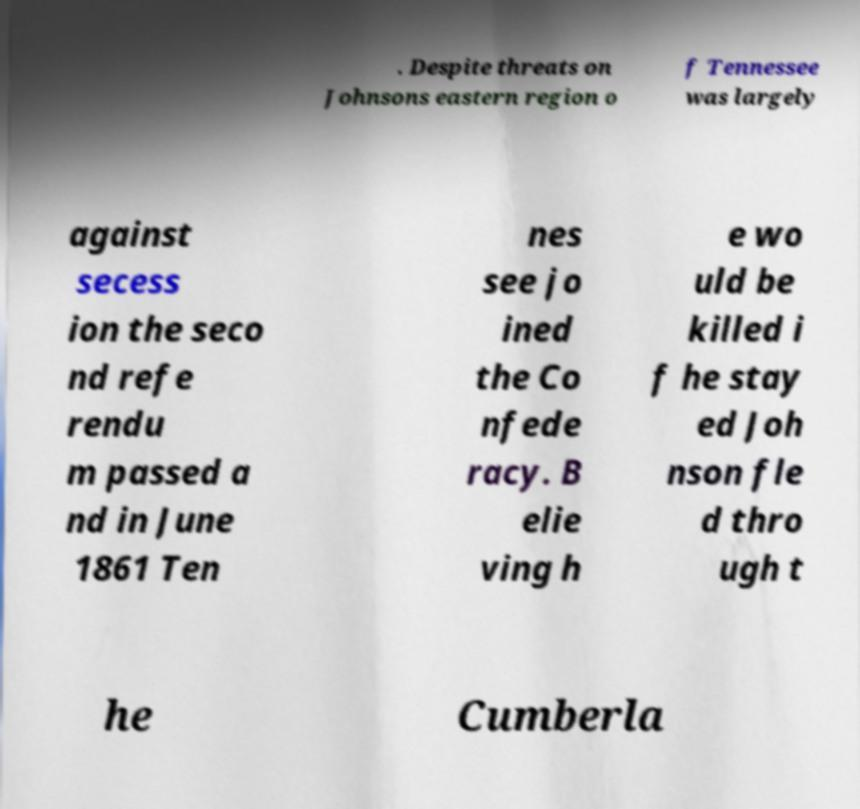For documentation purposes, I need the text within this image transcribed. Could you provide that? . Despite threats on Johnsons eastern region o f Tennessee was largely against secess ion the seco nd refe rendu m passed a nd in June 1861 Ten nes see jo ined the Co nfede racy. B elie ving h e wo uld be killed i f he stay ed Joh nson fle d thro ugh t he Cumberla 